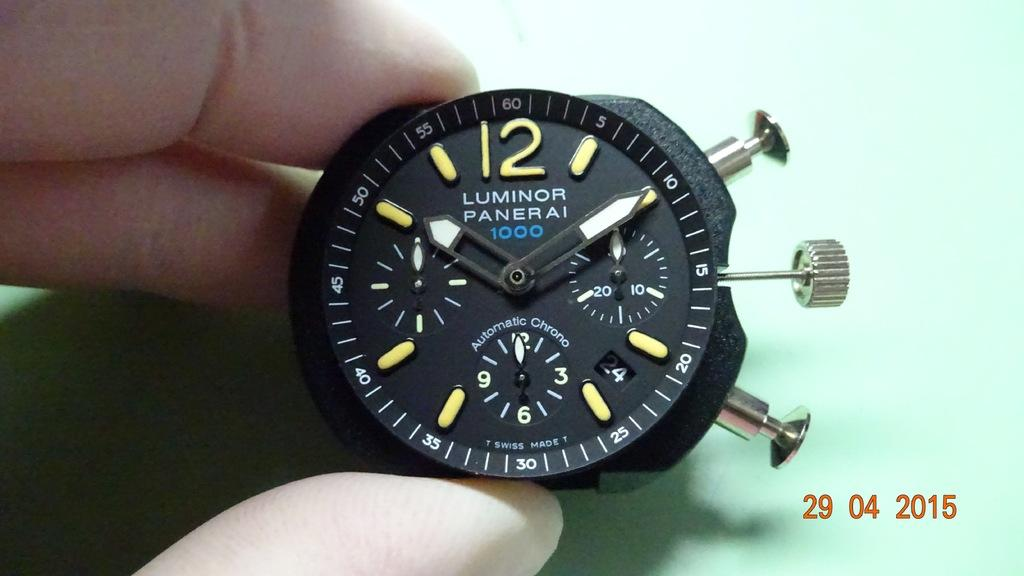<image>
Write a terse but informative summary of the picture. Fingers are holding a Luminor Paneri 1000 Automatic Chrono watch 